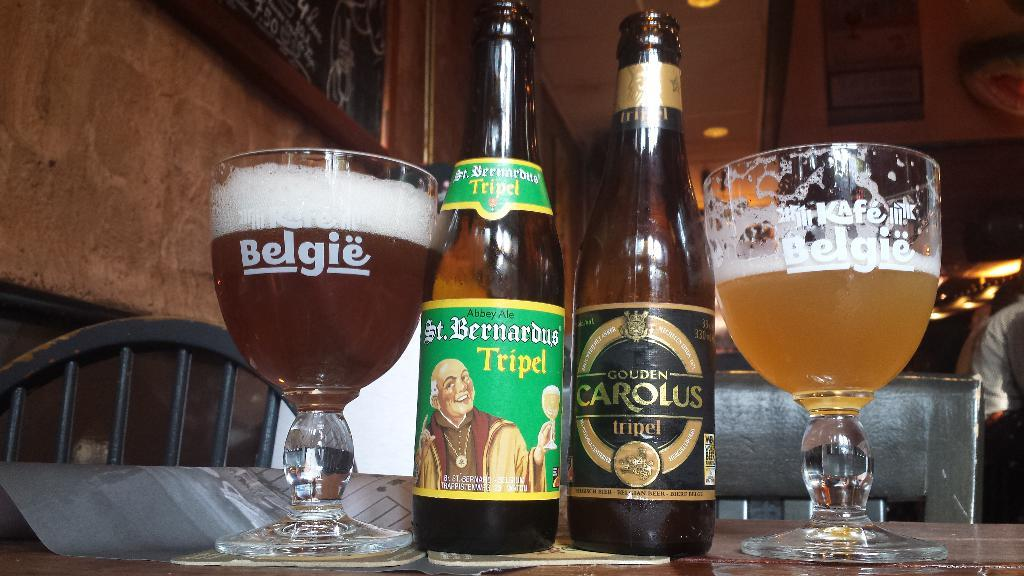<image>
Provide a brief description of the given image. Bottles of beer sit next to glasses marked Belgie 